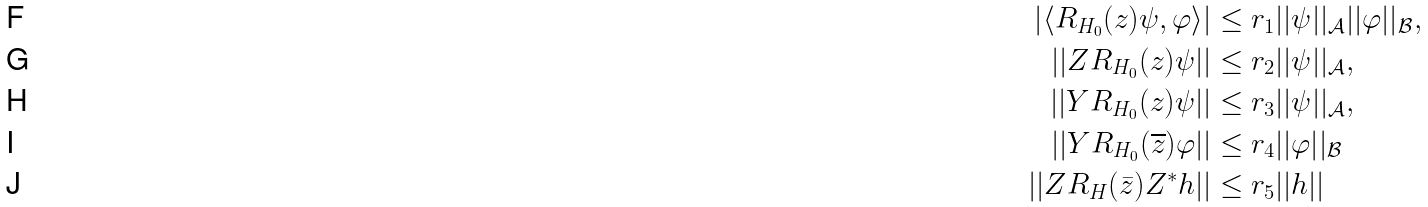<formula> <loc_0><loc_0><loc_500><loc_500>\left | \langle R _ { H _ { 0 } } ( z ) \psi , \varphi \rangle \right | & \leq r _ { 1 } | | \psi | | _ { \mathcal { A } } | | \varphi | | _ { \mathcal { B } } , \\ | | Z R _ { H _ { 0 } } ( z ) \psi | | & \leq r _ { 2 } | | \psi | | _ { \mathcal { A } } , \\ | | Y R _ { H _ { 0 } } ( z ) \psi | | & \leq r _ { 3 } | | \psi | | _ { \mathcal { A } } , \\ | | Y R _ { H _ { 0 } } ( \overline { z } ) \varphi | | & \leq r _ { 4 } | | \varphi | | _ { \mathcal { B } } \\ | | Z R _ { H } ( \bar { z } ) Z ^ { * } h | | & \leq r _ { 5 } | | h | |</formula> 